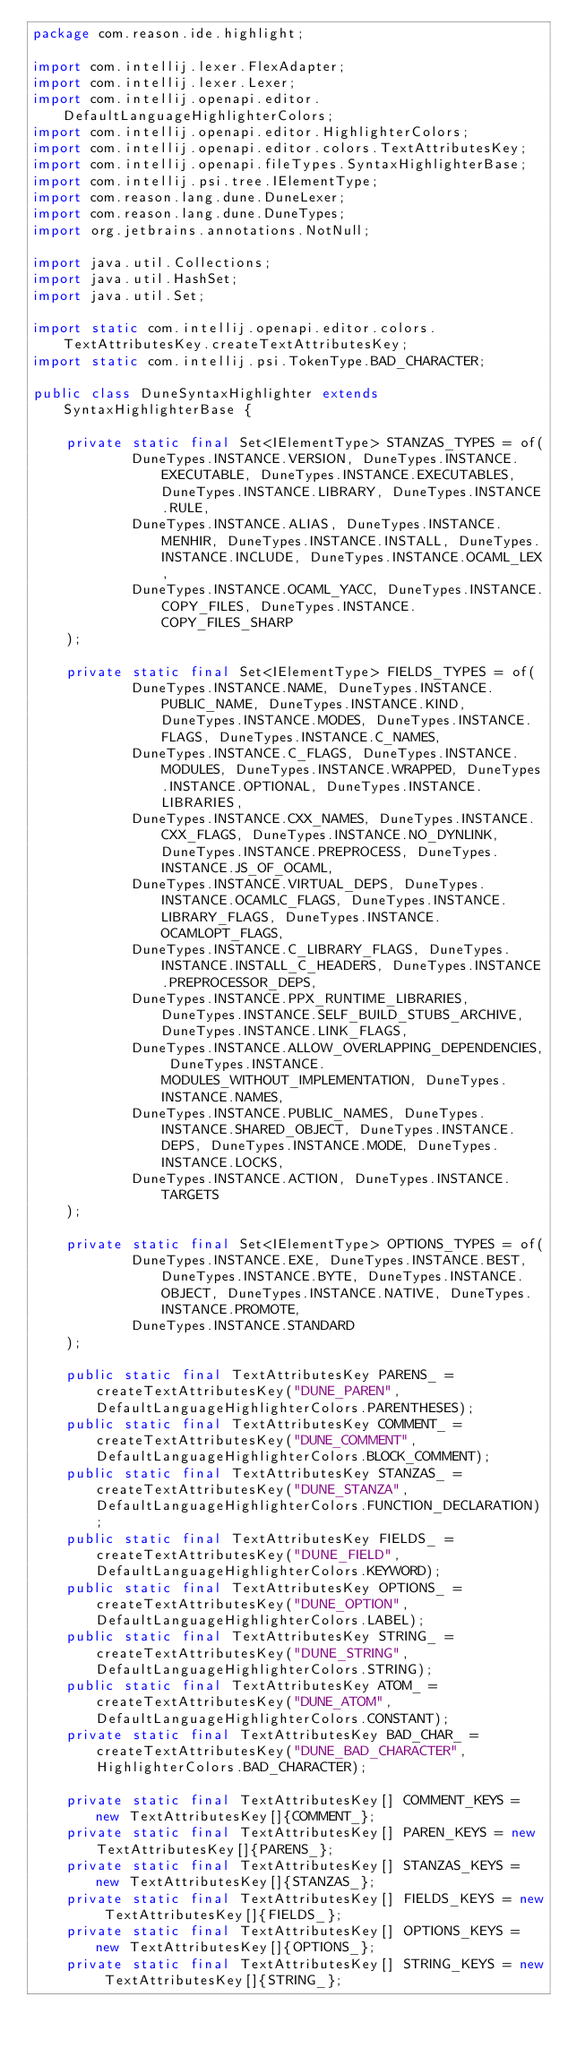Convert code to text. <code><loc_0><loc_0><loc_500><loc_500><_Java_>package com.reason.ide.highlight;

import com.intellij.lexer.FlexAdapter;
import com.intellij.lexer.Lexer;
import com.intellij.openapi.editor.DefaultLanguageHighlighterColors;
import com.intellij.openapi.editor.HighlighterColors;
import com.intellij.openapi.editor.colors.TextAttributesKey;
import com.intellij.openapi.fileTypes.SyntaxHighlighterBase;
import com.intellij.psi.tree.IElementType;
import com.reason.lang.dune.DuneLexer;
import com.reason.lang.dune.DuneTypes;
import org.jetbrains.annotations.NotNull;

import java.util.Collections;
import java.util.HashSet;
import java.util.Set;

import static com.intellij.openapi.editor.colors.TextAttributesKey.createTextAttributesKey;
import static com.intellij.psi.TokenType.BAD_CHARACTER;

public class DuneSyntaxHighlighter extends SyntaxHighlighterBase {

    private static final Set<IElementType> STANZAS_TYPES = of(
            DuneTypes.INSTANCE.VERSION, DuneTypes.INSTANCE.EXECUTABLE, DuneTypes.INSTANCE.EXECUTABLES, DuneTypes.INSTANCE.LIBRARY, DuneTypes.INSTANCE.RULE,
            DuneTypes.INSTANCE.ALIAS, DuneTypes.INSTANCE.MENHIR, DuneTypes.INSTANCE.INSTALL, DuneTypes.INSTANCE.INCLUDE, DuneTypes.INSTANCE.OCAML_LEX,
            DuneTypes.INSTANCE.OCAML_YACC, DuneTypes.INSTANCE.COPY_FILES, DuneTypes.INSTANCE.COPY_FILES_SHARP
    );

    private static final Set<IElementType> FIELDS_TYPES = of(
            DuneTypes.INSTANCE.NAME, DuneTypes.INSTANCE.PUBLIC_NAME, DuneTypes.INSTANCE.KIND, DuneTypes.INSTANCE.MODES, DuneTypes.INSTANCE.FLAGS, DuneTypes.INSTANCE.C_NAMES,
            DuneTypes.INSTANCE.C_FLAGS, DuneTypes.INSTANCE.MODULES, DuneTypes.INSTANCE.WRAPPED, DuneTypes.INSTANCE.OPTIONAL, DuneTypes.INSTANCE.LIBRARIES,
            DuneTypes.INSTANCE.CXX_NAMES, DuneTypes.INSTANCE.CXX_FLAGS, DuneTypes.INSTANCE.NO_DYNLINK, DuneTypes.INSTANCE.PREPROCESS, DuneTypes.INSTANCE.JS_OF_OCAML,
            DuneTypes.INSTANCE.VIRTUAL_DEPS, DuneTypes.INSTANCE.OCAMLC_FLAGS, DuneTypes.INSTANCE.LIBRARY_FLAGS, DuneTypes.INSTANCE.OCAMLOPT_FLAGS,
            DuneTypes.INSTANCE.C_LIBRARY_FLAGS, DuneTypes.INSTANCE.INSTALL_C_HEADERS, DuneTypes.INSTANCE.PREPROCESSOR_DEPS,
            DuneTypes.INSTANCE.PPX_RUNTIME_LIBRARIES, DuneTypes.INSTANCE.SELF_BUILD_STUBS_ARCHIVE, DuneTypes.INSTANCE.LINK_FLAGS,
            DuneTypes.INSTANCE.ALLOW_OVERLAPPING_DEPENDENCIES, DuneTypes.INSTANCE.MODULES_WITHOUT_IMPLEMENTATION, DuneTypes.INSTANCE.NAMES,
            DuneTypes.INSTANCE.PUBLIC_NAMES, DuneTypes.INSTANCE.SHARED_OBJECT, DuneTypes.INSTANCE.DEPS, DuneTypes.INSTANCE.MODE, DuneTypes.INSTANCE.LOCKS,
            DuneTypes.INSTANCE.ACTION, DuneTypes.INSTANCE.TARGETS
    );

    private static final Set<IElementType> OPTIONS_TYPES = of(
            DuneTypes.INSTANCE.EXE, DuneTypes.INSTANCE.BEST, DuneTypes.INSTANCE.BYTE, DuneTypes.INSTANCE.OBJECT, DuneTypes.INSTANCE.NATIVE, DuneTypes.INSTANCE.PROMOTE,
            DuneTypes.INSTANCE.STANDARD
    );

    public static final TextAttributesKey PARENS_ = createTextAttributesKey("DUNE_PAREN", DefaultLanguageHighlighterColors.PARENTHESES);
    public static final TextAttributesKey COMMENT_ = createTextAttributesKey("DUNE_COMMENT", DefaultLanguageHighlighterColors.BLOCK_COMMENT);
    public static final TextAttributesKey STANZAS_ = createTextAttributesKey("DUNE_STANZA", DefaultLanguageHighlighterColors.FUNCTION_DECLARATION);
    public static final TextAttributesKey FIELDS_ = createTextAttributesKey("DUNE_FIELD", DefaultLanguageHighlighterColors.KEYWORD);
    public static final TextAttributesKey OPTIONS_ = createTextAttributesKey("DUNE_OPTION", DefaultLanguageHighlighterColors.LABEL);
    public static final TextAttributesKey STRING_ = createTextAttributesKey("DUNE_STRING", DefaultLanguageHighlighterColors.STRING);
    public static final TextAttributesKey ATOM_ = createTextAttributesKey("DUNE_ATOM", DefaultLanguageHighlighterColors.CONSTANT);
    private static final TextAttributesKey BAD_CHAR_ = createTextAttributesKey("DUNE_BAD_CHARACTER", HighlighterColors.BAD_CHARACTER);

    private static final TextAttributesKey[] COMMENT_KEYS = new TextAttributesKey[]{COMMENT_};
    private static final TextAttributesKey[] PAREN_KEYS = new TextAttributesKey[]{PARENS_};
    private static final TextAttributesKey[] STANZAS_KEYS = new TextAttributesKey[]{STANZAS_};
    private static final TextAttributesKey[] FIELDS_KEYS = new TextAttributesKey[]{FIELDS_};
    private static final TextAttributesKey[] OPTIONS_KEYS = new TextAttributesKey[]{OPTIONS_};
    private static final TextAttributesKey[] STRING_KEYS = new TextAttributesKey[]{STRING_};</code> 